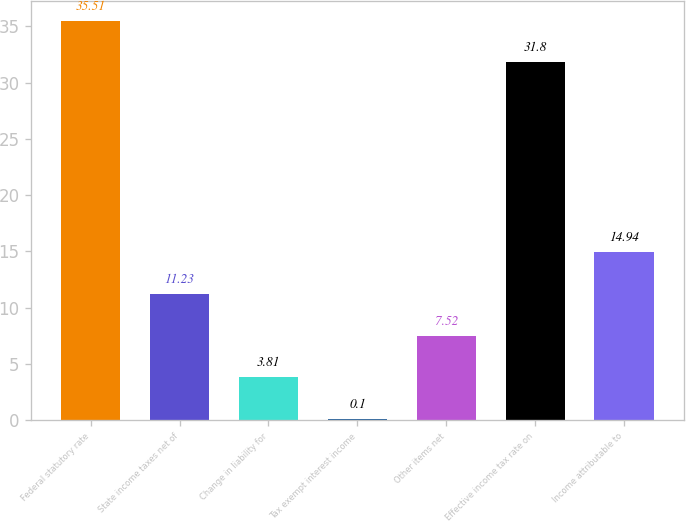<chart> <loc_0><loc_0><loc_500><loc_500><bar_chart><fcel>Federal statutory rate<fcel>State income taxes net of<fcel>Change in liability for<fcel>Tax exempt interest income<fcel>Other items net<fcel>Effective income tax rate on<fcel>Income attributable to<nl><fcel>35.51<fcel>11.23<fcel>3.81<fcel>0.1<fcel>7.52<fcel>31.8<fcel>14.94<nl></chart> 